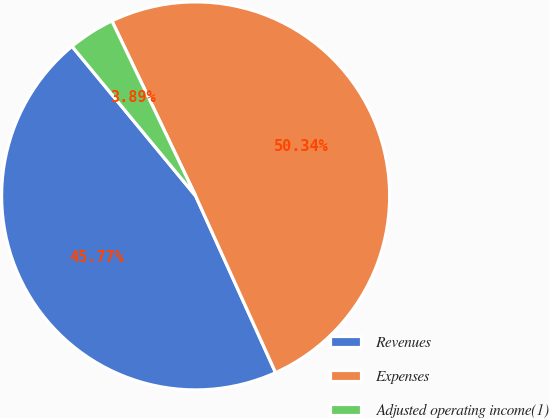Convert chart. <chart><loc_0><loc_0><loc_500><loc_500><pie_chart><fcel>Revenues<fcel>Expenses<fcel>Adjusted operating income(1)<nl><fcel>45.77%<fcel>50.34%<fcel>3.89%<nl></chart> 